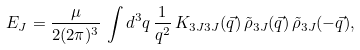<formula> <loc_0><loc_0><loc_500><loc_500>E _ { J } = \frac { \mu } { 2 ( 2 \pi ) ^ { 3 } } \, \int d ^ { 3 } q \, \frac { 1 } { q ^ { 2 } } \, K _ { 3 J 3 J } ( \vec { q } ) \, \tilde { \rho } _ { 3 J } ( \vec { q } ) \, \tilde { \rho } _ { 3 J } ( - \vec { q } ) ,</formula> 